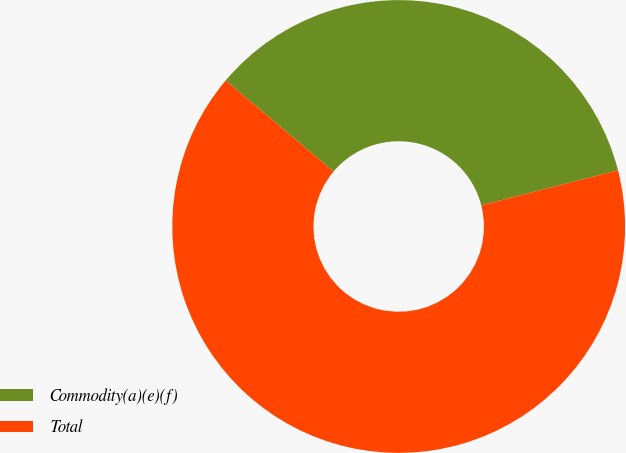Convert chart to OTSL. <chart><loc_0><loc_0><loc_500><loc_500><pie_chart><fcel>Commodity(a)(e)(f)<fcel>Total<nl><fcel>34.85%<fcel>65.15%<nl></chart> 